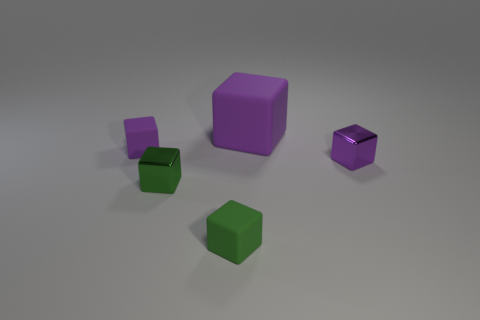Are there an equal number of small purple cubes on the right side of the green rubber cube and large matte objects to the right of the tiny green metal cube?
Your answer should be compact. Yes. How many blocks are either tiny green objects or large purple things?
Give a very brief answer. 3. How many other purple blocks have the same material as the large purple block?
Offer a very short reply. 1. There is a matte thing that is the same color as the large rubber cube; what shape is it?
Make the answer very short. Cube. The purple block that is both on the right side of the green rubber cube and in front of the big cube is made of what material?
Offer a terse response. Metal. The small object that is behind the purple metal object has what shape?
Provide a short and direct response. Cube. There is a tiny object that is behind the purple thing that is right of the large purple object; what is its shape?
Offer a terse response. Cube. Is there another big rubber thing of the same shape as the big object?
Keep it short and to the point. No. What is the shape of the green object that is the same size as the green matte cube?
Your response must be concise. Cube. There is a purple matte cube right of the tiny block that is behind the small purple shiny block; are there any tiny purple things that are on the right side of it?
Make the answer very short. Yes. 